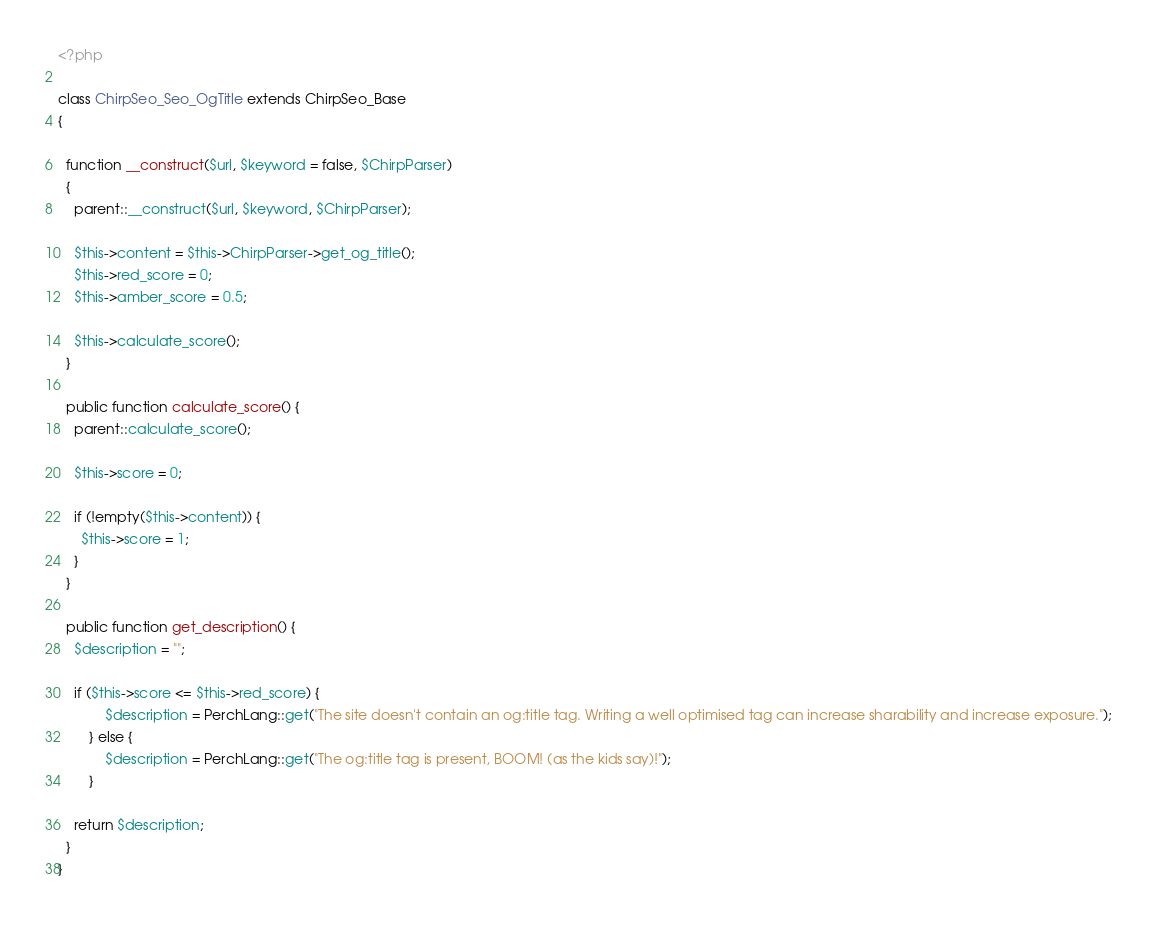<code> <loc_0><loc_0><loc_500><loc_500><_PHP_><?php

class ChirpSeo_Seo_OgTitle extends ChirpSeo_Base
{

  function __construct($url, $keyword = false, $ChirpParser)
  {
    parent::__construct($url, $keyword, $ChirpParser);

    $this->content = $this->ChirpParser->get_og_title();
    $this->red_score = 0;
    $this->amber_score = 0.5;

    $this->calculate_score();
  }

  public function calculate_score() {
    parent::calculate_score();

    $this->score = 0;

    if (!empty($this->content)) {
      $this->score = 1;
    }
  }

  public function get_description() {
    $description = "";

    if ($this->score <= $this->red_score) {
			$description = PerchLang::get("The site doesn't contain an og:title tag. Writing a well optimised tag can increase sharability and increase exposure.");
		} else {
			$description = PerchLang::get("The og:title tag is present, BOOM! (as the kids say)!");
		}

    return $description;
  }
}
</code> 